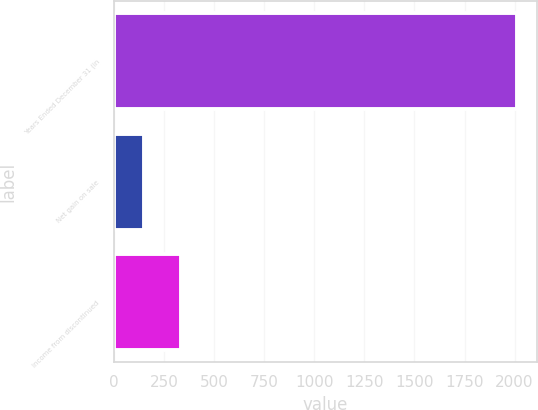<chart> <loc_0><loc_0><loc_500><loc_500><bar_chart><fcel>Years Ended December 31 (in<fcel>Net gain on sale<fcel>Income from discontinued<nl><fcel>2013<fcel>150<fcel>336.3<nl></chart> 